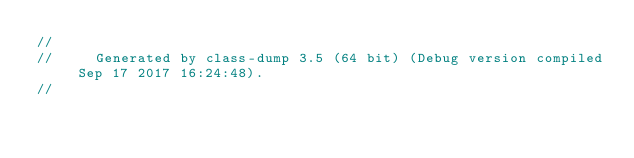<code> <loc_0><loc_0><loc_500><loc_500><_C_>//
//     Generated by class-dump 3.5 (64 bit) (Debug version compiled Sep 17 2017 16:24:48).
//</code> 